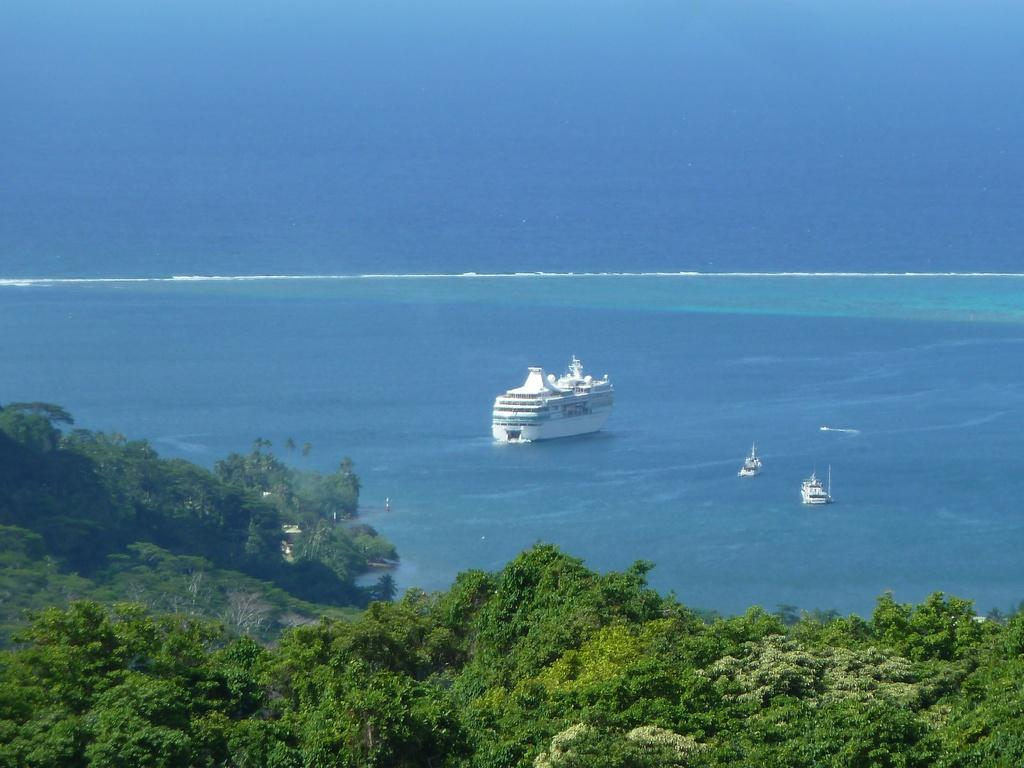What type of vegetation is in the foreground of the image? There are trees in the foreground of the image. What natural feature can be seen in the background of the image? There is an ocean visible in the background of the image. What is floating in the water in the image? There are ships in the water. What type of pain can be seen on the faces of the people in the image? There are no people present in the image, only trees, an ocean, and ships. How much dust is visible on the surface of the water in the image? There is no dust visible on the surface of the water in the image. 